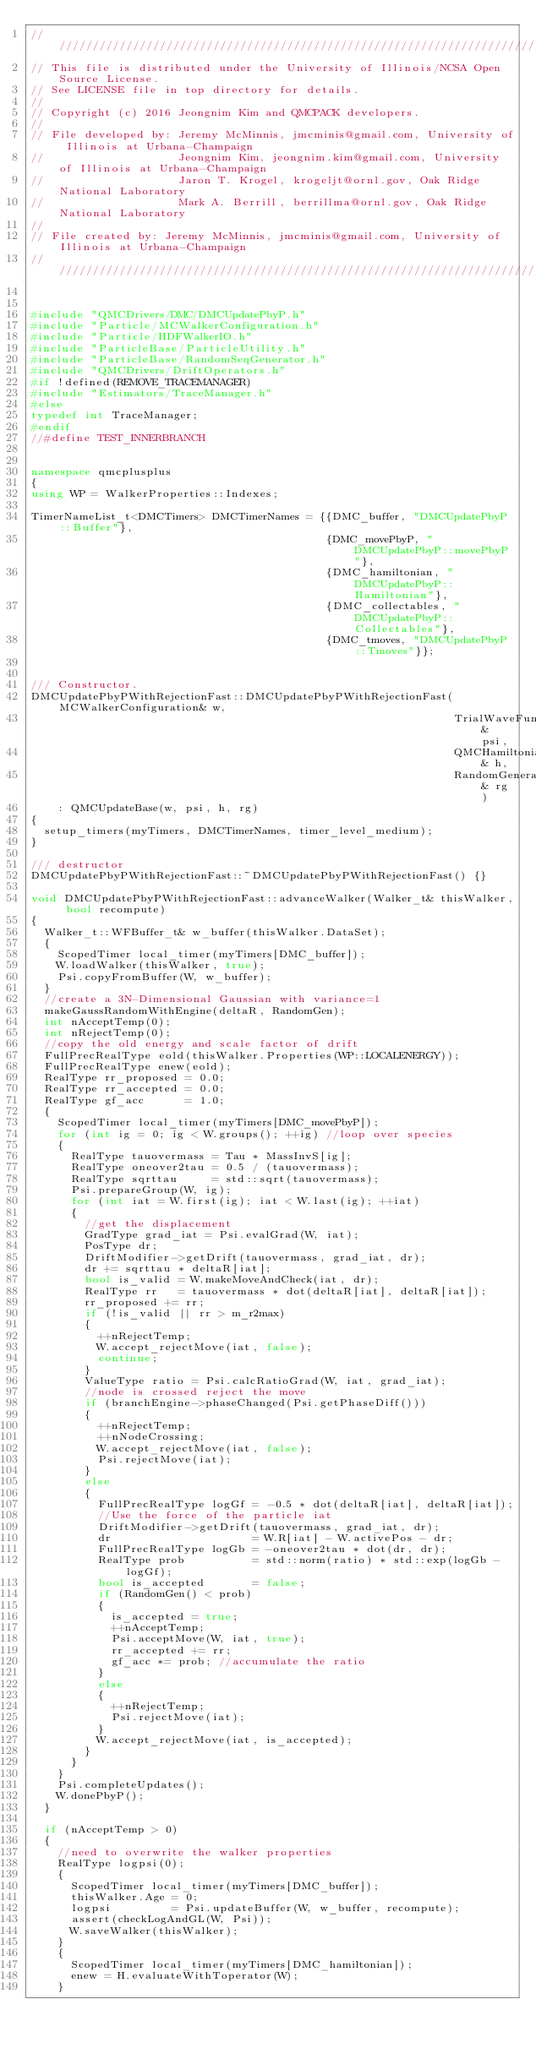Convert code to text. <code><loc_0><loc_0><loc_500><loc_500><_C++_>//////////////////////////////////////////////////////////////////////////////////////
// This file is distributed under the University of Illinois/NCSA Open Source License.
// See LICENSE file in top directory for details.
//
// Copyright (c) 2016 Jeongnim Kim and QMCPACK developers.
//
// File developed by: Jeremy McMinnis, jmcminis@gmail.com, University of Illinois at Urbana-Champaign
//                    Jeongnim Kim, jeongnim.kim@gmail.com, University of Illinois at Urbana-Champaign
//                    Jaron T. Krogel, krogeljt@ornl.gov, Oak Ridge National Laboratory
//                    Mark A. Berrill, berrillma@ornl.gov, Oak Ridge National Laboratory
//
// File created by: Jeremy McMinnis, jmcminis@gmail.com, University of Illinois at Urbana-Champaign
//////////////////////////////////////////////////////////////////////////////////////


#include "QMCDrivers/DMC/DMCUpdatePbyP.h"
#include "Particle/MCWalkerConfiguration.h"
#include "Particle/HDFWalkerIO.h"
#include "ParticleBase/ParticleUtility.h"
#include "ParticleBase/RandomSeqGenerator.h"
#include "QMCDrivers/DriftOperators.h"
#if !defined(REMOVE_TRACEMANAGER)
#include "Estimators/TraceManager.h"
#else
typedef int TraceManager;
#endif
//#define TEST_INNERBRANCH


namespace qmcplusplus
{
using WP = WalkerProperties::Indexes;

TimerNameList_t<DMCTimers> DMCTimerNames = {{DMC_buffer, "DMCUpdatePbyP::Buffer"},
                                            {DMC_movePbyP, "DMCUpdatePbyP::movePbyP"},
                                            {DMC_hamiltonian, "DMCUpdatePbyP::Hamiltonian"},
                                            {DMC_collectables, "DMCUpdatePbyP::Collectables"},
                                            {DMC_tmoves, "DMCUpdatePbyP::Tmoves"}};


/// Constructor.
DMCUpdatePbyPWithRejectionFast::DMCUpdatePbyPWithRejectionFast(MCWalkerConfiguration& w,
                                                               TrialWaveFunction& psi,
                                                               QMCHamiltonian& h,
                                                               RandomGenerator_t& rg)
    : QMCUpdateBase(w, psi, h, rg)
{
  setup_timers(myTimers, DMCTimerNames, timer_level_medium);
}

/// destructor
DMCUpdatePbyPWithRejectionFast::~DMCUpdatePbyPWithRejectionFast() {}

void DMCUpdatePbyPWithRejectionFast::advanceWalker(Walker_t& thisWalker, bool recompute)
{
  Walker_t::WFBuffer_t& w_buffer(thisWalker.DataSet);
  {
    ScopedTimer local_timer(myTimers[DMC_buffer]);
    W.loadWalker(thisWalker, true);
    Psi.copyFromBuffer(W, w_buffer);
  }
  //create a 3N-Dimensional Gaussian with variance=1
  makeGaussRandomWithEngine(deltaR, RandomGen);
  int nAcceptTemp(0);
  int nRejectTemp(0);
  //copy the old energy and scale factor of drift
  FullPrecRealType eold(thisWalker.Properties(WP::LOCALENERGY));
  FullPrecRealType enew(eold);
  RealType rr_proposed = 0.0;
  RealType rr_accepted = 0.0;
  RealType gf_acc      = 1.0;
  {
    ScopedTimer local_timer(myTimers[DMC_movePbyP]);
    for (int ig = 0; ig < W.groups(); ++ig) //loop over species
    {
      RealType tauovermass = Tau * MassInvS[ig];
      RealType oneover2tau = 0.5 / (tauovermass);
      RealType sqrttau     = std::sqrt(tauovermass);
      Psi.prepareGroup(W, ig);
      for (int iat = W.first(ig); iat < W.last(ig); ++iat)
      {
        //get the displacement
        GradType grad_iat = Psi.evalGrad(W, iat);
        PosType dr;
        DriftModifier->getDrift(tauovermass, grad_iat, dr);
        dr += sqrttau * deltaR[iat];
        bool is_valid = W.makeMoveAndCheck(iat, dr);
        RealType rr   = tauovermass * dot(deltaR[iat], deltaR[iat]);
        rr_proposed += rr;
        if (!is_valid || rr > m_r2max)
        {
          ++nRejectTemp;
          W.accept_rejectMove(iat, false);
          continue;
        }
        ValueType ratio = Psi.calcRatioGrad(W, iat, grad_iat);
        //node is crossed reject the move
        if (branchEngine->phaseChanged(Psi.getPhaseDiff()))
        {
          ++nRejectTemp;
          ++nNodeCrossing;
          W.accept_rejectMove(iat, false);
          Psi.rejectMove(iat);
        }
        else
        {
          FullPrecRealType logGf = -0.5 * dot(deltaR[iat], deltaR[iat]);
          //Use the force of the particle iat
          DriftModifier->getDrift(tauovermass, grad_iat, dr);
          dr                     = W.R[iat] - W.activePos - dr;
          FullPrecRealType logGb = -oneover2tau * dot(dr, dr);
          RealType prob          = std::norm(ratio) * std::exp(logGb - logGf);
          bool is_accepted       = false;
          if (RandomGen() < prob)
          {
            is_accepted = true;
            ++nAcceptTemp;
            Psi.acceptMove(W, iat, true);
            rr_accepted += rr;
            gf_acc *= prob; //accumulate the ratio
          }
          else
          {
            ++nRejectTemp;
            Psi.rejectMove(iat);
          }
          W.accept_rejectMove(iat, is_accepted);
        }
      }
    }
    Psi.completeUpdates();
    W.donePbyP();
  }

  if (nAcceptTemp > 0)
  {
    //need to overwrite the walker properties
    RealType logpsi(0);
    {
      ScopedTimer local_timer(myTimers[DMC_buffer]);
      thisWalker.Age = 0;
      logpsi         = Psi.updateBuffer(W, w_buffer, recompute);
      assert(checkLogAndGL(W, Psi));
      W.saveWalker(thisWalker);
    }
    {
      ScopedTimer local_timer(myTimers[DMC_hamiltonian]);
      enew = H.evaluateWithToperator(W);
    }</code> 